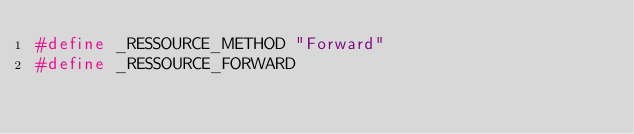<code> <loc_0><loc_0><loc_500><loc_500><_C++_>#define _RESSOURCE_METHOD "Forward"
#define _RESSOURCE_FORWARD

</code> 